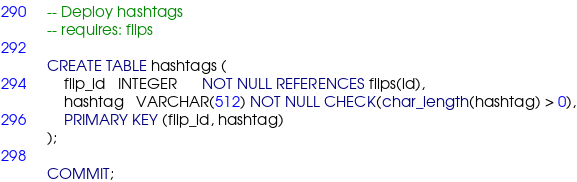<code> <loc_0><loc_0><loc_500><loc_500><_SQL_>-- Deploy hashtags
-- requires: flips

CREATE TABLE hashtags (
    flip_id   INTEGER      NOT NULL REFERENCES flips(id),
    hashtag   VARCHAR(512) NOT NULL CHECK(char_length(hashtag) > 0),
    PRIMARY KEY (flip_id, hashtag)
);

COMMIT;
</code> 